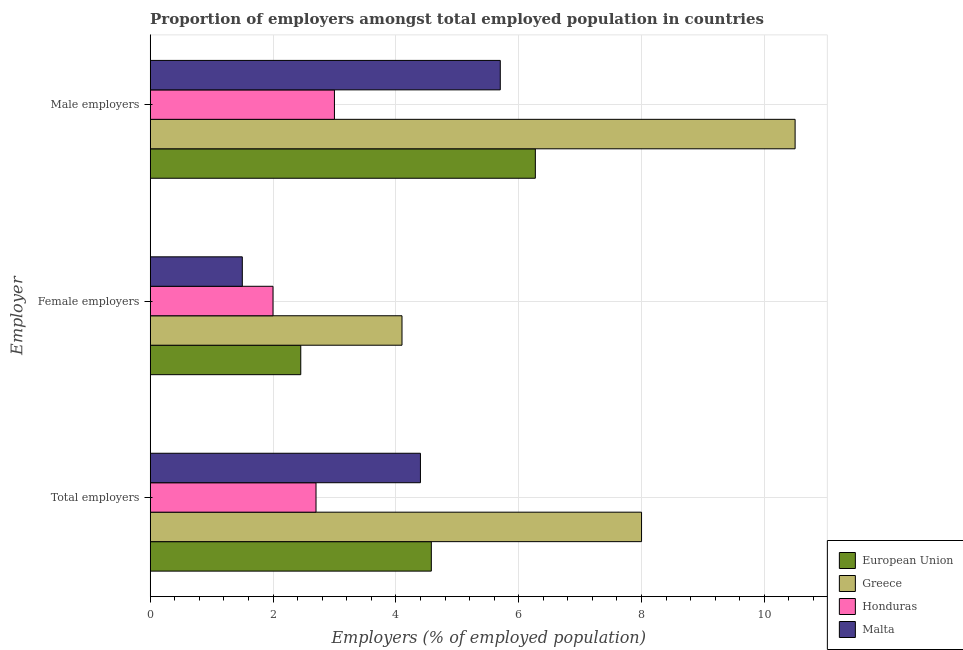How many different coloured bars are there?
Provide a succinct answer. 4. How many groups of bars are there?
Ensure brevity in your answer.  3. Are the number of bars on each tick of the Y-axis equal?
Your response must be concise. Yes. How many bars are there on the 2nd tick from the top?
Provide a succinct answer. 4. What is the label of the 2nd group of bars from the top?
Your answer should be very brief. Female employers. What is the percentage of total employers in European Union?
Offer a very short reply. 4.58. Across all countries, what is the maximum percentage of female employers?
Your response must be concise. 4.1. Across all countries, what is the minimum percentage of female employers?
Your answer should be very brief. 1.5. In which country was the percentage of total employers maximum?
Keep it short and to the point. Greece. In which country was the percentage of total employers minimum?
Provide a short and direct response. Honduras. What is the total percentage of male employers in the graph?
Offer a terse response. 25.47. What is the difference between the percentage of female employers in Greece and that in Honduras?
Keep it short and to the point. 2.1. What is the difference between the percentage of total employers in European Union and the percentage of male employers in Honduras?
Make the answer very short. 1.58. What is the average percentage of male employers per country?
Ensure brevity in your answer.  6.37. What is the difference between the percentage of male employers and percentage of total employers in Malta?
Make the answer very short. 1.3. What is the ratio of the percentage of male employers in Malta to that in Greece?
Offer a very short reply. 0.54. Is the percentage of female employers in European Union less than that in Malta?
Provide a succinct answer. No. What is the difference between the highest and the second highest percentage of total employers?
Offer a terse response. 3.42. In how many countries, is the percentage of female employers greater than the average percentage of female employers taken over all countries?
Your answer should be very brief. 1. Is the sum of the percentage of female employers in Malta and Greece greater than the maximum percentage of male employers across all countries?
Your answer should be compact. No. What does the 2nd bar from the top in Female employers represents?
Offer a very short reply. Honduras. What does the 4th bar from the bottom in Female employers represents?
Provide a short and direct response. Malta. Is it the case that in every country, the sum of the percentage of total employers and percentage of female employers is greater than the percentage of male employers?
Your answer should be very brief. Yes. Are all the bars in the graph horizontal?
Keep it short and to the point. Yes. How many countries are there in the graph?
Your answer should be very brief. 4. Does the graph contain grids?
Offer a very short reply. Yes. Where does the legend appear in the graph?
Your answer should be very brief. Bottom right. How many legend labels are there?
Keep it short and to the point. 4. What is the title of the graph?
Offer a very short reply. Proportion of employers amongst total employed population in countries. What is the label or title of the X-axis?
Keep it short and to the point. Employers (% of employed population). What is the label or title of the Y-axis?
Your answer should be compact. Employer. What is the Employers (% of employed population) of European Union in Total employers?
Your response must be concise. 4.58. What is the Employers (% of employed population) of Greece in Total employers?
Keep it short and to the point. 8. What is the Employers (% of employed population) of Honduras in Total employers?
Your answer should be compact. 2.7. What is the Employers (% of employed population) in Malta in Total employers?
Give a very brief answer. 4.4. What is the Employers (% of employed population) in European Union in Female employers?
Keep it short and to the point. 2.45. What is the Employers (% of employed population) of Greece in Female employers?
Ensure brevity in your answer.  4.1. What is the Employers (% of employed population) of Honduras in Female employers?
Provide a succinct answer. 2. What is the Employers (% of employed population) in Malta in Female employers?
Offer a very short reply. 1.5. What is the Employers (% of employed population) of European Union in Male employers?
Give a very brief answer. 6.27. What is the Employers (% of employed population) of Greece in Male employers?
Give a very brief answer. 10.5. What is the Employers (% of employed population) of Malta in Male employers?
Offer a very short reply. 5.7. Across all Employer, what is the maximum Employers (% of employed population) in European Union?
Ensure brevity in your answer.  6.27. Across all Employer, what is the maximum Employers (% of employed population) of Honduras?
Your response must be concise. 3. Across all Employer, what is the maximum Employers (% of employed population) of Malta?
Give a very brief answer. 5.7. Across all Employer, what is the minimum Employers (% of employed population) of European Union?
Your answer should be very brief. 2.45. Across all Employer, what is the minimum Employers (% of employed population) in Greece?
Your answer should be compact. 4.1. Across all Employer, what is the minimum Employers (% of employed population) of Honduras?
Make the answer very short. 2. Across all Employer, what is the minimum Employers (% of employed population) in Malta?
Give a very brief answer. 1.5. What is the total Employers (% of employed population) in European Union in the graph?
Provide a succinct answer. 13.3. What is the total Employers (% of employed population) of Greece in the graph?
Give a very brief answer. 22.6. What is the difference between the Employers (% of employed population) of European Union in Total employers and that in Female employers?
Offer a very short reply. 2.13. What is the difference between the Employers (% of employed population) of Greece in Total employers and that in Female employers?
Make the answer very short. 3.9. What is the difference between the Employers (% of employed population) of Honduras in Total employers and that in Female employers?
Provide a succinct answer. 0.7. What is the difference between the Employers (% of employed population) in European Union in Total employers and that in Male employers?
Your answer should be compact. -1.69. What is the difference between the Employers (% of employed population) of Honduras in Total employers and that in Male employers?
Ensure brevity in your answer.  -0.3. What is the difference between the Employers (% of employed population) of European Union in Female employers and that in Male employers?
Your answer should be very brief. -3.82. What is the difference between the Employers (% of employed population) in Honduras in Female employers and that in Male employers?
Your answer should be compact. -1. What is the difference between the Employers (% of employed population) of European Union in Total employers and the Employers (% of employed population) of Greece in Female employers?
Make the answer very short. 0.48. What is the difference between the Employers (% of employed population) of European Union in Total employers and the Employers (% of employed population) of Honduras in Female employers?
Make the answer very short. 2.58. What is the difference between the Employers (% of employed population) of European Union in Total employers and the Employers (% of employed population) of Malta in Female employers?
Offer a terse response. 3.08. What is the difference between the Employers (% of employed population) in Greece in Total employers and the Employers (% of employed population) in Honduras in Female employers?
Provide a succinct answer. 6. What is the difference between the Employers (% of employed population) in European Union in Total employers and the Employers (% of employed population) in Greece in Male employers?
Ensure brevity in your answer.  -5.92. What is the difference between the Employers (% of employed population) in European Union in Total employers and the Employers (% of employed population) in Honduras in Male employers?
Your answer should be very brief. 1.58. What is the difference between the Employers (% of employed population) in European Union in Total employers and the Employers (% of employed population) in Malta in Male employers?
Make the answer very short. -1.12. What is the difference between the Employers (% of employed population) of Greece in Total employers and the Employers (% of employed population) of Malta in Male employers?
Your response must be concise. 2.3. What is the difference between the Employers (% of employed population) of European Union in Female employers and the Employers (% of employed population) of Greece in Male employers?
Offer a terse response. -8.05. What is the difference between the Employers (% of employed population) in European Union in Female employers and the Employers (% of employed population) in Honduras in Male employers?
Your response must be concise. -0.55. What is the difference between the Employers (% of employed population) in European Union in Female employers and the Employers (% of employed population) in Malta in Male employers?
Give a very brief answer. -3.25. What is the average Employers (% of employed population) of European Union per Employer?
Make the answer very short. 4.43. What is the average Employers (% of employed population) in Greece per Employer?
Your answer should be very brief. 7.53. What is the average Employers (% of employed population) in Honduras per Employer?
Provide a short and direct response. 2.57. What is the average Employers (% of employed population) in Malta per Employer?
Your response must be concise. 3.87. What is the difference between the Employers (% of employed population) in European Union and Employers (% of employed population) in Greece in Total employers?
Offer a terse response. -3.42. What is the difference between the Employers (% of employed population) of European Union and Employers (% of employed population) of Honduras in Total employers?
Provide a succinct answer. 1.88. What is the difference between the Employers (% of employed population) in European Union and Employers (% of employed population) in Malta in Total employers?
Your answer should be very brief. 0.18. What is the difference between the Employers (% of employed population) of Greece and Employers (% of employed population) of Malta in Total employers?
Your answer should be very brief. 3.6. What is the difference between the Employers (% of employed population) in European Union and Employers (% of employed population) in Greece in Female employers?
Your answer should be very brief. -1.65. What is the difference between the Employers (% of employed population) in European Union and Employers (% of employed population) in Honduras in Female employers?
Offer a terse response. 0.45. What is the difference between the Employers (% of employed population) in European Union and Employers (% of employed population) in Malta in Female employers?
Offer a terse response. 0.95. What is the difference between the Employers (% of employed population) in Greece and Employers (% of employed population) in Malta in Female employers?
Offer a very short reply. 2.6. What is the difference between the Employers (% of employed population) in Honduras and Employers (% of employed population) in Malta in Female employers?
Provide a short and direct response. 0.5. What is the difference between the Employers (% of employed population) in European Union and Employers (% of employed population) in Greece in Male employers?
Offer a very short reply. -4.23. What is the difference between the Employers (% of employed population) in European Union and Employers (% of employed population) in Honduras in Male employers?
Give a very brief answer. 3.27. What is the difference between the Employers (% of employed population) in European Union and Employers (% of employed population) in Malta in Male employers?
Your response must be concise. 0.57. What is the difference between the Employers (% of employed population) of Greece and Employers (% of employed population) of Honduras in Male employers?
Give a very brief answer. 7.5. What is the difference between the Employers (% of employed population) of Greece and Employers (% of employed population) of Malta in Male employers?
Ensure brevity in your answer.  4.8. What is the ratio of the Employers (% of employed population) in European Union in Total employers to that in Female employers?
Your answer should be compact. 1.87. What is the ratio of the Employers (% of employed population) in Greece in Total employers to that in Female employers?
Give a very brief answer. 1.95. What is the ratio of the Employers (% of employed population) in Honduras in Total employers to that in Female employers?
Provide a succinct answer. 1.35. What is the ratio of the Employers (% of employed population) of Malta in Total employers to that in Female employers?
Your answer should be compact. 2.93. What is the ratio of the Employers (% of employed population) in European Union in Total employers to that in Male employers?
Offer a terse response. 0.73. What is the ratio of the Employers (% of employed population) in Greece in Total employers to that in Male employers?
Provide a short and direct response. 0.76. What is the ratio of the Employers (% of employed population) in Malta in Total employers to that in Male employers?
Provide a short and direct response. 0.77. What is the ratio of the Employers (% of employed population) of European Union in Female employers to that in Male employers?
Your answer should be very brief. 0.39. What is the ratio of the Employers (% of employed population) of Greece in Female employers to that in Male employers?
Ensure brevity in your answer.  0.39. What is the ratio of the Employers (% of employed population) in Honduras in Female employers to that in Male employers?
Provide a short and direct response. 0.67. What is the ratio of the Employers (% of employed population) of Malta in Female employers to that in Male employers?
Your answer should be compact. 0.26. What is the difference between the highest and the second highest Employers (% of employed population) in European Union?
Offer a very short reply. 1.69. What is the difference between the highest and the second highest Employers (% of employed population) in Greece?
Make the answer very short. 2.5. What is the difference between the highest and the lowest Employers (% of employed population) in European Union?
Your answer should be very brief. 3.82. What is the difference between the highest and the lowest Employers (% of employed population) in Honduras?
Offer a terse response. 1. What is the difference between the highest and the lowest Employers (% of employed population) of Malta?
Provide a short and direct response. 4.2. 